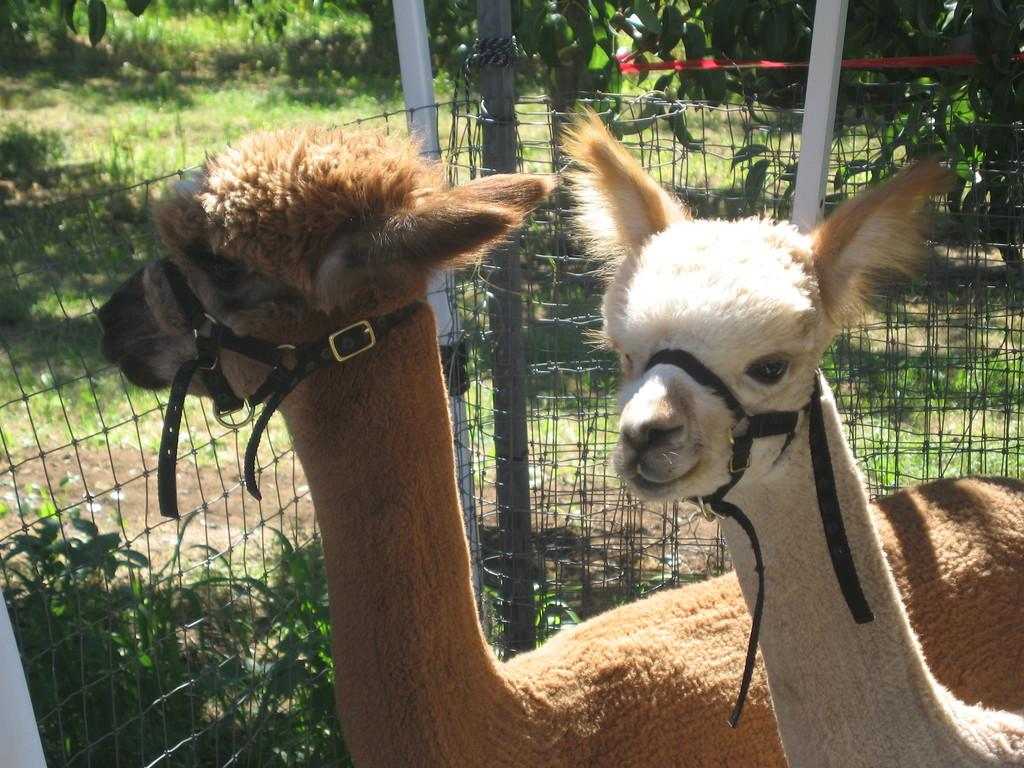What type of living organisms can be seen in the image? There are animals in the image. Can you describe the color of the animals? The animals are in brown and cream color. What can be seen in the background of the image? There is a railing and trees visible in the background of the image. What is the color of the trees in the background? The trees in the background are green in color. What type of payment is being made in the image? There is no payment being made in the image; it features animals and a background with trees and a railing. 